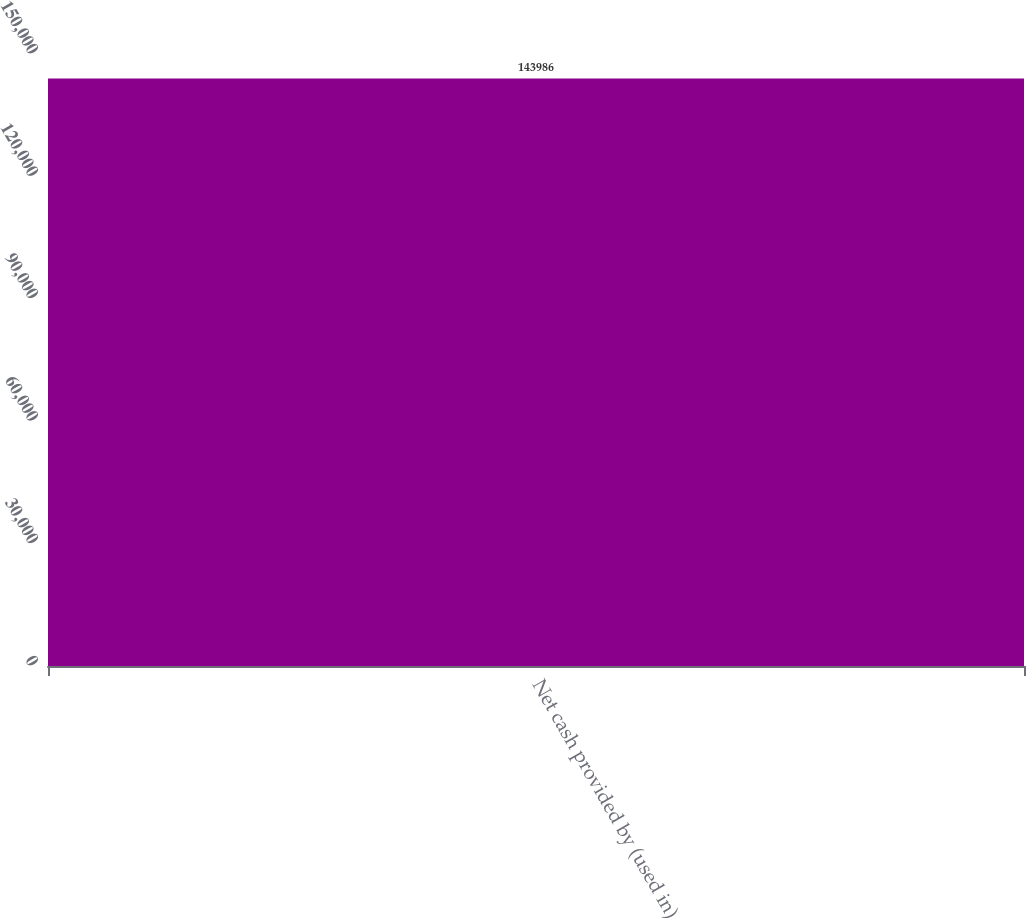Convert chart to OTSL. <chart><loc_0><loc_0><loc_500><loc_500><bar_chart><fcel>Net cash provided by (used in)<nl><fcel>143986<nl></chart> 